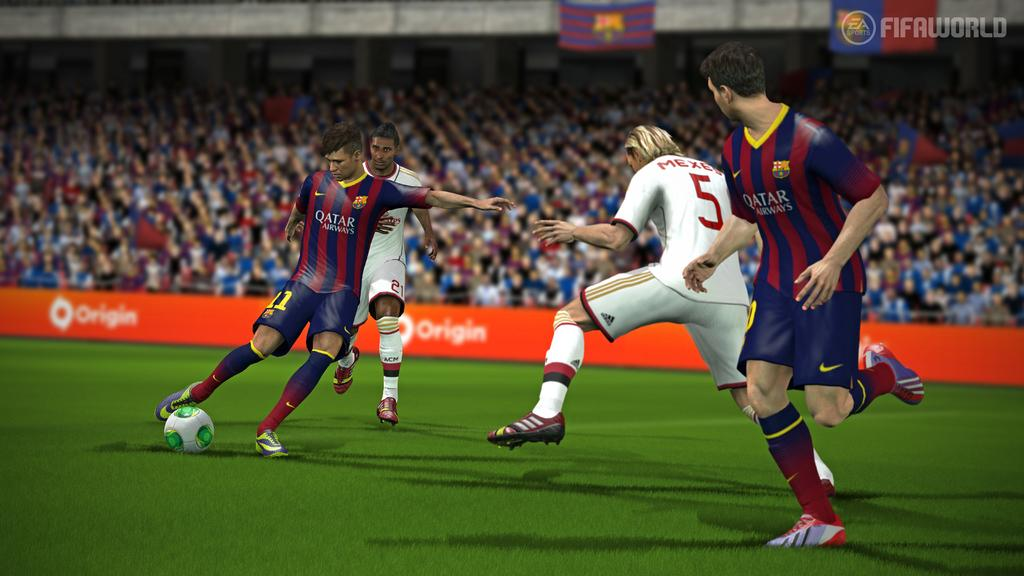<image>
Give a short and clear explanation of the subsequent image. A game of soccer from FIFA that is sponsored by origin 